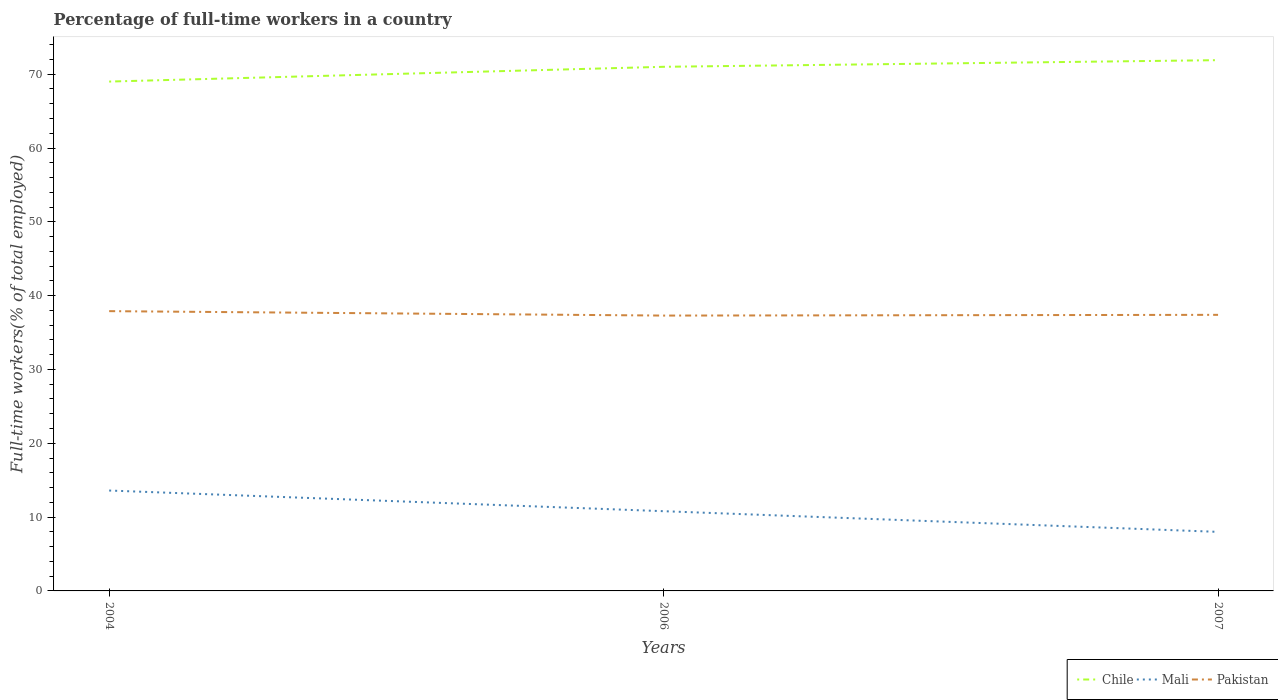How many different coloured lines are there?
Your answer should be compact. 3. Does the line corresponding to Pakistan intersect with the line corresponding to Mali?
Keep it short and to the point. No. Is the number of lines equal to the number of legend labels?
Ensure brevity in your answer.  Yes. In which year was the percentage of full-time workers in Pakistan maximum?
Offer a very short reply. 2006. What is the total percentage of full-time workers in Chile in the graph?
Give a very brief answer. -2.9. What is the difference between the highest and the second highest percentage of full-time workers in Chile?
Your answer should be very brief. 2.9. Is the percentage of full-time workers in Pakistan strictly greater than the percentage of full-time workers in Chile over the years?
Keep it short and to the point. Yes. How many lines are there?
Your response must be concise. 3. How many years are there in the graph?
Provide a short and direct response. 3. What is the difference between two consecutive major ticks on the Y-axis?
Your response must be concise. 10. How many legend labels are there?
Your answer should be very brief. 3. What is the title of the graph?
Make the answer very short. Percentage of full-time workers in a country. Does "Palau" appear as one of the legend labels in the graph?
Make the answer very short. No. What is the label or title of the X-axis?
Your answer should be very brief. Years. What is the label or title of the Y-axis?
Provide a succinct answer. Full-time workers(% of total employed). What is the Full-time workers(% of total employed) of Mali in 2004?
Your answer should be very brief. 13.6. What is the Full-time workers(% of total employed) of Pakistan in 2004?
Your answer should be very brief. 37.9. What is the Full-time workers(% of total employed) of Mali in 2006?
Keep it short and to the point. 10.8. What is the Full-time workers(% of total employed) in Pakistan in 2006?
Your answer should be very brief. 37.3. What is the Full-time workers(% of total employed) in Chile in 2007?
Offer a terse response. 71.9. What is the Full-time workers(% of total employed) in Pakistan in 2007?
Provide a short and direct response. 37.4. Across all years, what is the maximum Full-time workers(% of total employed) of Chile?
Offer a very short reply. 71.9. Across all years, what is the maximum Full-time workers(% of total employed) of Mali?
Your answer should be very brief. 13.6. Across all years, what is the maximum Full-time workers(% of total employed) in Pakistan?
Give a very brief answer. 37.9. Across all years, what is the minimum Full-time workers(% of total employed) in Chile?
Offer a terse response. 69. Across all years, what is the minimum Full-time workers(% of total employed) in Mali?
Ensure brevity in your answer.  8. Across all years, what is the minimum Full-time workers(% of total employed) in Pakistan?
Keep it short and to the point. 37.3. What is the total Full-time workers(% of total employed) in Chile in the graph?
Offer a very short reply. 211.9. What is the total Full-time workers(% of total employed) of Mali in the graph?
Keep it short and to the point. 32.4. What is the total Full-time workers(% of total employed) of Pakistan in the graph?
Keep it short and to the point. 112.6. What is the difference between the Full-time workers(% of total employed) in Pakistan in 2004 and that in 2006?
Keep it short and to the point. 0.6. What is the difference between the Full-time workers(% of total employed) in Pakistan in 2004 and that in 2007?
Give a very brief answer. 0.5. What is the difference between the Full-time workers(% of total employed) in Mali in 2006 and that in 2007?
Make the answer very short. 2.8. What is the difference between the Full-time workers(% of total employed) of Chile in 2004 and the Full-time workers(% of total employed) of Mali in 2006?
Your answer should be compact. 58.2. What is the difference between the Full-time workers(% of total employed) of Chile in 2004 and the Full-time workers(% of total employed) of Pakistan in 2006?
Your answer should be very brief. 31.7. What is the difference between the Full-time workers(% of total employed) in Mali in 2004 and the Full-time workers(% of total employed) in Pakistan in 2006?
Your answer should be compact. -23.7. What is the difference between the Full-time workers(% of total employed) in Chile in 2004 and the Full-time workers(% of total employed) in Mali in 2007?
Give a very brief answer. 61. What is the difference between the Full-time workers(% of total employed) of Chile in 2004 and the Full-time workers(% of total employed) of Pakistan in 2007?
Make the answer very short. 31.6. What is the difference between the Full-time workers(% of total employed) of Mali in 2004 and the Full-time workers(% of total employed) of Pakistan in 2007?
Offer a terse response. -23.8. What is the difference between the Full-time workers(% of total employed) of Chile in 2006 and the Full-time workers(% of total employed) of Mali in 2007?
Provide a short and direct response. 63. What is the difference between the Full-time workers(% of total employed) of Chile in 2006 and the Full-time workers(% of total employed) of Pakistan in 2007?
Keep it short and to the point. 33.6. What is the difference between the Full-time workers(% of total employed) of Mali in 2006 and the Full-time workers(% of total employed) of Pakistan in 2007?
Your response must be concise. -26.6. What is the average Full-time workers(% of total employed) in Chile per year?
Your response must be concise. 70.63. What is the average Full-time workers(% of total employed) of Pakistan per year?
Your answer should be very brief. 37.53. In the year 2004, what is the difference between the Full-time workers(% of total employed) of Chile and Full-time workers(% of total employed) of Mali?
Provide a short and direct response. 55.4. In the year 2004, what is the difference between the Full-time workers(% of total employed) of Chile and Full-time workers(% of total employed) of Pakistan?
Ensure brevity in your answer.  31.1. In the year 2004, what is the difference between the Full-time workers(% of total employed) in Mali and Full-time workers(% of total employed) in Pakistan?
Ensure brevity in your answer.  -24.3. In the year 2006, what is the difference between the Full-time workers(% of total employed) in Chile and Full-time workers(% of total employed) in Mali?
Your answer should be very brief. 60.2. In the year 2006, what is the difference between the Full-time workers(% of total employed) of Chile and Full-time workers(% of total employed) of Pakistan?
Ensure brevity in your answer.  33.7. In the year 2006, what is the difference between the Full-time workers(% of total employed) in Mali and Full-time workers(% of total employed) in Pakistan?
Provide a short and direct response. -26.5. In the year 2007, what is the difference between the Full-time workers(% of total employed) of Chile and Full-time workers(% of total employed) of Mali?
Keep it short and to the point. 63.9. In the year 2007, what is the difference between the Full-time workers(% of total employed) of Chile and Full-time workers(% of total employed) of Pakistan?
Provide a succinct answer. 34.5. In the year 2007, what is the difference between the Full-time workers(% of total employed) in Mali and Full-time workers(% of total employed) in Pakistan?
Ensure brevity in your answer.  -29.4. What is the ratio of the Full-time workers(% of total employed) of Chile in 2004 to that in 2006?
Make the answer very short. 0.97. What is the ratio of the Full-time workers(% of total employed) of Mali in 2004 to that in 2006?
Provide a succinct answer. 1.26. What is the ratio of the Full-time workers(% of total employed) of Pakistan in 2004 to that in 2006?
Provide a succinct answer. 1.02. What is the ratio of the Full-time workers(% of total employed) in Chile in 2004 to that in 2007?
Provide a succinct answer. 0.96. What is the ratio of the Full-time workers(% of total employed) in Mali in 2004 to that in 2007?
Your answer should be very brief. 1.7. What is the ratio of the Full-time workers(% of total employed) in Pakistan in 2004 to that in 2007?
Offer a very short reply. 1.01. What is the ratio of the Full-time workers(% of total employed) of Chile in 2006 to that in 2007?
Your answer should be very brief. 0.99. What is the ratio of the Full-time workers(% of total employed) in Mali in 2006 to that in 2007?
Provide a short and direct response. 1.35. What is the ratio of the Full-time workers(% of total employed) in Pakistan in 2006 to that in 2007?
Ensure brevity in your answer.  1. What is the difference between the highest and the second highest Full-time workers(% of total employed) of Chile?
Make the answer very short. 0.9. What is the difference between the highest and the second highest Full-time workers(% of total employed) of Mali?
Offer a very short reply. 2.8. What is the difference between the highest and the second highest Full-time workers(% of total employed) in Pakistan?
Keep it short and to the point. 0.5. What is the difference between the highest and the lowest Full-time workers(% of total employed) of Chile?
Offer a terse response. 2.9. What is the difference between the highest and the lowest Full-time workers(% of total employed) in Mali?
Give a very brief answer. 5.6. What is the difference between the highest and the lowest Full-time workers(% of total employed) in Pakistan?
Your answer should be very brief. 0.6. 